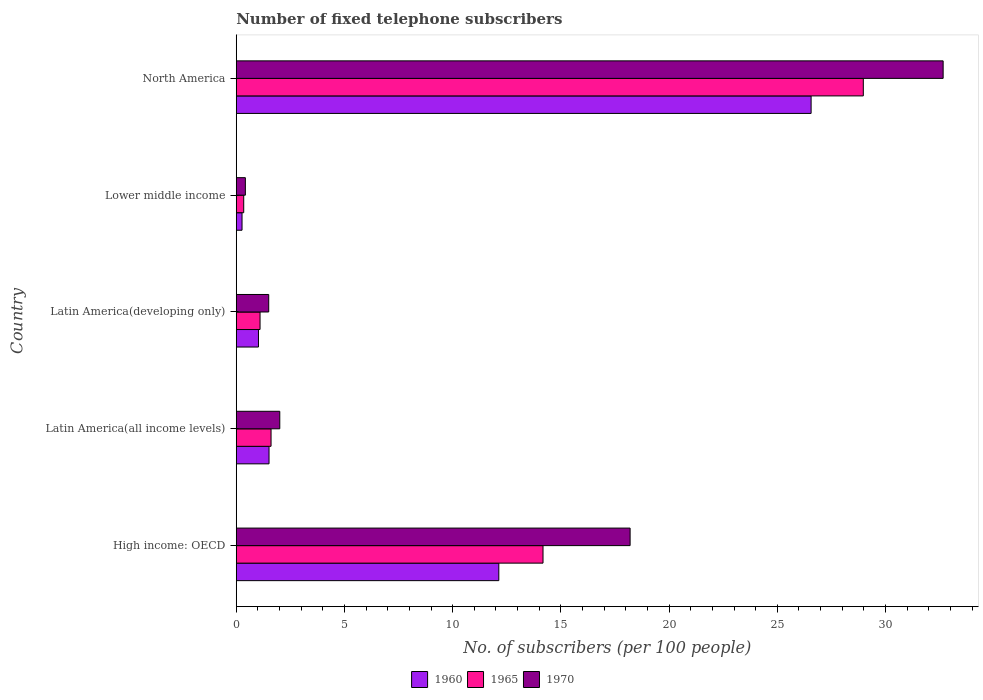How many different coloured bars are there?
Your response must be concise. 3. How many groups of bars are there?
Ensure brevity in your answer.  5. Are the number of bars on each tick of the Y-axis equal?
Offer a terse response. Yes. How many bars are there on the 3rd tick from the top?
Offer a terse response. 3. How many bars are there on the 4th tick from the bottom?
Give a very brief answer. 3. What is the label of the 2nd group of bars from the top?
Offer a terse response. Lower middle income. What is the number of fixed telephone subscribers in 1965 in North America?
Offer a very short reply. 28.97. Across all countries, what is the maximum number of fixed telephone subscribers in 1970?
Offer a terse response. 32.66. Across all countries, what is the minimum number of fixed telephone subscribers in 1965?
Keep it short and to the point. 0.34. In which country was the number of fixed telephone subscribers in 1970 minimum?
Your answer should be very brief. Lower middle income. What is the total number of fixed telephone subscribers in 1970 in the graph?
Make the answer very short. 54.79. What is the difference between the number of fixed telephone subscribers in 1970 in High income: OECD and that in Latin America(developing only)?
Give a very brief answer. 16.7. What is the difference between the number of fixed telephone subscribers in 1960 in North America and the number of fixed telephone subscribers in 1965 in Latin America(all income levels)?
Your response must be concise. 24.95. What is the average number of fixed telephone subscribers in 1960 per country?
Provide a succinct answer. 8.3. What is the difference between the number of fixed telephone subscribers in 1965 and number of fixed telephone subscribers in 1970 in High income: OECD?
Offer a terse response. -4.02. What is the ratio of the number of fixed telephone subscribers in 1970 in High income: OECD to that in North America?
Give a very brief answer. 0.56. What is the difference between the highest and the second highest number of fixed telephone subscribers in 1960?
Make the answer very short. 14.43. What is the difference between the highest and the lowest number of fixed telephone subscribers in 1970?
Give a very brief answer. 32.24. Is the sum of the number of fixed telephone subscribers in 1970 in High income: OECD and Latin America(all income levels) greater than the maximum number of fixed telephone subscribers in 1965 across all countries?
Offer a very short reply. No. What does the 2nd bar from the top in Lower middle income represents?
Your answer should be very brief. 1965. What does the 1st bar from the bottom in North America represents?
Your answer should be very brief. 1960. How many bars are there?
Your response must be concise. 15. Are all the bars in the graph horizontal?
Ensure brevity in your answer.  Yes. How many countries are there in the graph?
Your response must be concise. 5. Does the graph contain any zero values?
Provide a short and direct response. No. Does the graph contain grids?
Your response must be concise. No. Where does the legend appear in the graph?
Provide a succinct answer. Bottom center. How many legend labels are there?
Your answer should be very brief. 3. How are the legend labels stacked?
Offer a terse response. Horizontal. What is the title of the graph?
Provide a succinct answer. Number of fixed telephone subscribers. Does "2011" appear as one of the legend labels in the graph?
Provide a succinct answer. No. What is the label or title of the X-axis?
Your answer should be compact. No. of subscribers (per 100 people). What is the label or title of the Y-axis?
Make the answer very short. Country. What is the No. of subscribers (per 100 people) in 1960 in High income: OECD?
Give a very brief answer. 12.13. What is the No. of subscribers (per 100 people) in 1965 in High income: OECD?
Your answer should be very brief. 14.17. What is the No. of subscribers (per 100 people) in 1970 in High income: OECD?
Make the answer very short. 18.2. What is the No. of subscribers (per 100 people) of 1960 in Latin America(all income levels)?
Your answer should be very brief. 1.51. What is the No. of subscribers (per 100 people) in 1965 in Latin America(all income levels)?
Provide a succinct answer. 1.61. What is the No. of subscribers (per 100 people) in 1970 in Latin America(all income levels)?
Ensure brevity in your answer.  2.01. What is the No. of subscribers (per 100 people) in 1960 in Latin America(developing only)?
Make the answer very short. 1.03. What is the No. of subscribers (per 100 people) of 1965 in Latin America(developing only)?
Ensure brevity in your answer.  1.1. What is the No. of subscribers (per 100 people) in 1970 in Latin America(developing only)?
Provide a succinct answer. 1.5. What is the No. of subscribers (per 100 people) of 1960 in Lower middle income?
Your response must be concise. 0.27. What is the No. of subscribers (per 100 people) of 1965 in Lower middle income?
Your response must be concise. 0.34. What is the No. of subscribers (per 100 people) in 1970 in Lower middle income?
Offer a very short reply. 0.42. What is the No. of subscribers (per 100 people) in 1960 in North America?
Your response must be concise. 26.56. What is the No. of subscribers (per 100 people) in 1965 in North America?
Your answer should be compact. 28.97. What is the No. of subscribers (per 100 people) in 1970 in North America?
Your answer should be very brief. 32.66. Across all countries, what is the maximum No. of subscribers (per 100 people) in 1960?
Ensure brevity in your answer.  26.56. Across all countries, what is the maximum No. of subscribers (per 100 people) in 1965?
Your response must be concise. 28.97. Across all countries, what is the maximum No. of subscribers (per 100 people) of 1970?
Your answer should be very brief. 32.66. Across all countries, what is the minimum No. of subscribers (per 100 people) of 1960?
Your response must be concise. 0.27. Across all countries, what is the minimum No. of subscribers (per 100 people) of 1965?
Your response must be concise. 0.34. Across all countries, what is the minimum No. of subscribers (per 100 people) of 1970?
Keep it short and to the point. 0.42. What is the total No. of subscribers (per 100 people) of 1960 in the graph?
Ensure brevity in your answer.  41.5. What is the total No. of subscribers (per 100 people) of 1965 in the graph?
Ensure brevity in your answer.  46.2. What is the total No. of subscribers (per 100 people) in 1970 in the graph?
Offer a very short reply. 54.79. What is the difference between the No. of subscribers (per 100 people) of 1960 in High income: OECD and that in Latin America(all income levels)?
Offer a very short reply. 10.62. What is the difference between the No. of subscribers (per 100 people) in 1965 in High income: OECD and that in Latin America(all income levels)?
Your response must be concise. 12.57. What is the difference between the No. of subscribers (per 100 people) in 1970 in High income: OECD and that in Latin America(all income levels)?
Offer a very short reply. 16.19. What is the difference between the No. of subscribers (per 100 people) in 1960 in High income: OECD and that in Latin America(developing only)?
Your answer should be compact. 11.1. What is the difference between the No. of subscribers (per 100 people) in 1965 in High income: OECD and that in Latin America(developing only)?
Your response must be concise. 13.07. What is the difference between the No. of subscribers (per 100 people) in 1970 in High income: OECD and that in Latin America(developing only)?
Keep it short and to the point. 16.7. What is the difference between the No. of subscribers (per 100 people) in 1960 in High income: OECD and that in Lower middle income?
Offer a terse response. 11.86. What is the difference between the No. of subscribers (per 100 people) in 1965 in High income: OECD and that in Lower middle income?
Your response must be concise. 13.83. What is the difference between the No. of subscribers (per 100 people) in 1970 in High income: OECD and that in Lower middle income?
Provide a succinct answer. 17.78. What is the difference between the No. of subscribers (per 100 people) in 1960 in High income: OECD and that in North America?
Keep it short and to the point. -14.43. What is the difference between the No. of subscribers (per 100 people) of 1965 in High income: OECD and that in North America?
Give a very brief answer. -14.8. What is the difference between the No. of subscribers (per 100 people) in 1970 in High income: OECD and that in North America?
Offer a very short reply. -14.46. What is the difference between the No. of subscribers (per 100 people) of 1960 in Latin America(all income levels) and that in Latin America(developing only)?
Provide a succinct answer. 0.49. What is the difference between the No. of subscribers (per 100 people) of 1965 in Latin America(all income levels) and that in Latin America(developing only)?
Your response must be concise. 0.51. What is the difference between the No. of subscribers (per 100 people) in 1970 in Latin America(all income levels) and that in Latin America(developing only)?
Make the answer very short. 0.51. What is the difference between the No. of subscribers (per 100 people) of 1960 in Latin America(all income levels) and that in Lower middle income?
Offer a very short reply. 1.25. What is the difference between the No. of subscribers (per 100 people) in 1965 in Latin America(all income levels) and that in Lower middle income?
Your answer should be compact. 1.26. What is the difference between the No. of subscribers (per 100 people) of 1970 in Latin America(all income levels) and that in Lower middle income?
Offer a terse response. 1.59. What is the difference between the No. of subscribers (per 100 people) in 1960 in Latin America(all income levels) and that in North America?
Your answer should be very brief. -25.05. What is the difference between the No. of subscribers (per 100 people) of 1965 in Latin America(all income levels) and that in North America?
Make the answer very short. -27.36. What is the difference between the No. of subscribers (per 100 people) of 1970 in Latin America(all income levels) and that in North America?
Your response must be concise. -30.65. What is the difference between the No. of subscribers (per 100 people) in 1960 in Latin America(developing only) and that in Lower middle income?
Your answer should be very brief. 0.76. What is the difference between the No. of subscribers (per 100 people) in 1965 in Latin America(developing only) and that in Lower middle income?
Offer a very short reply. 0.75. What is the difference between the No. of subscribers (per 100 people) of 1970 in Latin America(developing only) and that in Lower middle income?
Provide a short and direct response. 1.08. What is the difference between the No. of subscribers (per 100 people) of 1960 in Latin America(developing only) and that in North America?
Provide a succinct answer. -25.53. What is the difference between the No. of subscribers (per 100 people) of 1965 in Latin America(developing only) and that in North America?
Offer a terse response. -27.87. What is the difference between the No. of subscribers (per 100 people) in 1970 in Latin America(developing only) and that in North America?
Provide a succinct answer. -31.16. What is the difference between the No. of subscribers (per 100 people) in 1960 in Lower middle income and that in North America?
Make the answer very short. -26.29. What is the difference between the No. of subscribers (per 100 people) of 1965 in Lower middle income and that in North America?
Offer a terse response. -28.63. What is the difference between the No. of subscribers (per 100 people) of 1970 in Lower middle income and that in North America?
Provide a succinct answer. -32.24. What is the difference between the No. of subscribers (per 100 people) of 1960 in High income: OECD and the No. of subscribers (per 100 people) of 1965 in Latin America(all income levels)?
Provide a succinct answer. 10.52. What is the difference between the No. of subscribers (per 100 people) in 1960 in High income: OECD and the No. of subscribers (per 100 people) in 1970 in Latin America(all income levels)?
Provide a succinct answer. 10.12. What is the difference between the No. of subscribers (per 100 people) in 1965 in High income: OECD and the No. of subscribers (per 100 people) in 1970 in Latin America(all income levels)?
Your response must be concise. 12.16. What is the difference between the No. of subscribers (per 100 people) in 1960 in High income: OECD and the No. of subscribers (per 100 people) in 1965 in Latin America(developing only)?
Give a very brief answer. 11.03. What is the difference between the No. of subscribers (per 100 people) in 1960 in High income: OECD and the No. of subscribers (per 100 people) in 1970 in Latin America(developing only)?
Your response must be concise. 10.63. What is the difference between the No. of subscribers (per 100 people) of 1965 in High income: OECD and the No. of subscribers (per 100 people) of 1970 in Latin America(developing only)?
Give a very brief answer. 12.67. What is the difference between the No. of subscribers (per 100 people) in 1960 in High income: OECD and the No. of subscribers (per 100 people) in 1965 in Lower middle income?
Your answer should be compact. 11.79. What is the difference between the No. of subscribers (per 100 people) in 1960 in High income: OECD and the No. of subscribers (per 100 people) in 1970 in Lower middle income?
Your response must be concise. 11.71. What is the difference between the No. of subscribers (per 100 people) of 1965 in High income: OECD and the No. of subscribers (per 100 people) of 1970 in Lower middle income?
Provide a succinct answer. 13.75. What is the difference between the No. of subscribers (per 100 people) in 1960 in High income: OECD and the No. of subscribers (per 100 people) in 1965 in North America?
Your response must be concise. -16.84. What is the difference between the No. of subscribers (per 100 people) of 1960 in High income: OECD and the No. of subscribers (per 100 people) of 1970 in North America?
Keep it short and to the point. -20.53. What is the difference between the No. of subscribers (per 100 people) of 1965 in High income: OECD and the No. of subscribers (per 100 people) of 1970 in North America?
Offer a terse response. -18.49. What is the difference between the No. of subscribers (per 100 people) in 1960 in Latin America(all income levels) and the No. of subscribers (per 100 people) in 1965 in Latin America(developing only)?
Provide a succinct answer. 0.41. What is the difference between the No. of subscribers (per 100 people) in 1960 in Latin America(all income levels) and the No. of subscribers (per 100 people) in 1970 in Latin America(developing only)?
Make the answer very short. 0.01. What is the difference between the No. of subscribers (per 100 people) of 1965 in Latin America(all income levels) and the No. of subscribers (per 100 people) of 1970 in Latin America(developing only)?
Your answer should be very brief. 0.11. What is the difference between the No. of subscribers (per 100 people) of 1960 in Latin America(all income levels) and the No. of subscribers (per 100 people) of 1965 in Lower middle income?
Provide a short and direct response. 1.17. What is the difference between the No. of subscribers (per 100 people) in 1960 in Latin America(all income levels) and the No. of subscribers (per 100 people) in 1970 in Lower middle income?
Offer a very short reply. 1.09. What is the difference between the No. of subscribers (per 100 people) in 1965 in Latin America(all income levels) and the No. of subscribers (per 100 people) in 1970 in Lower middle income?
Ensure brevity in your answer.  1.19. What is the difference between the No. of subscribers (per 100 people) in 1960 in Latin America(all income levels) and the No. of subscribers (per 100 people) in 1965 in North America?
Keep it short and to the point. -27.46. What is the difference between the No. of subscribers (per 100 people) in 1960 in Latin America(all income levels) and the No. of subscribers (per 100 people) in 1970 in North America?
Offer a very short reply. -31.15. What is the difference between the No. of subscribers (per 100 people) of 1965 in Latin America(all income levels) and the No. of subscribers (per 100 people) of 1970 in North America?
Give a very brief answer. -31.05. What is the difference between the No. of subscribers (per 100 people) of 1960 in Latin America(developing only) and the No. of subscribers (per 100 people) of 1965 in Lower middle income?
Keep it short and to the point. 0.68. What is the difference between the No. of subscribers (per 100 people) of 1960 in Latin America(developing only) and the No. of subscribers (per 100 people) of 1970 in Lower middle income?
Provide a succinct answer. 0.61. What is the difference between the No. of subscribers (per 100 people) of 1965 in Latin America(developing only) and the No. of subscribers (per 100 people) of 1970 in Lower middle income?
Provide a succinct answer. 0.68. What is the difference between the No. of subscribers (per 100 people) in 1960 in Latin America(developing only) and the No. of subscribers (per 100 people) in 1965 in North America?
Provide a succinct answer. -27.94. What is the difference between the No. of subscribers (per 100 people) in 1960 in Latin America(developing only) and the No. of subscribers (per 100 people) in 1970 in North America?
Provide a short and direct response. -31.63. What is the difference between the No. of subscribers (per 100 people) in 1965 in Latin America(developing only) and the No. of subscribers (per 100 people) in 1970 in North America?
Provide a short and direct response. -31.56. What is the difference between the No. of subscribers (per 100 people) of 1960 in Lower middle income and the No. of subscribers (per 100 people) of 1965 in North America?
Provide a succinct answer. -28.7. What is the difference between the No. of subscribers (per 100 people) in 1960 in Lower middle income and the No. of subscribers (per 100 people) in 1970 in North America?
Give a very brief answer. -32.39. What is the difference between the No. of subscribers (per 100 people) in 1965 in Lower middle income and the No. of subscribers (per 100 people) in 1970 in North America?
Offer a very short reply. -32.32. What is the average No. of subscribers (per 100 people) in 1960 per country?
Your answer should be very brief. 8.3. What is the average No. of subscribers (per 100 people) in 1965 per country?
Your answer should be very brief. 9.24. What is the average No. of subscribers (per 100 people) of 1970 per country?
Your answer should be very brief. 10.96. What is the difference between the No. of subscribers (per 100 people) in 1960 and No. of subscribers (per 100 people) in 1965 in High income: OECD?
Your response must be concise. -2.04. What is the difference between the No. of subscribers (per 100 people) in 1960 and No. of subscribers (per 100 people) in 1970 in High income: OECD?
Your response must be concise. -6.07. What is the difference between the No. of subscribers (per 100 people) in 1965 and No. of subscribers (per 100 people) in 1970 in High income: OECD?
Provide a succinct answer. -4.02. What is the difference between the No. of subscribers (per 100 people) of 1960 and No. of subscribers (per 100 people) of 1965 in Latin America(all income levels)?
Make the answer very short. -0.09. What is the difference between the No. of subscribers (per 100 people) of 1960 and No. of subscribers (per 100 people) of 1970 in Latin America(all income levels)?
Make the answer very short. -0.5. What is the difference between the No. of subscribers (per 100 people) of 1965 and No. of subscribers (per 100 people) of 1970 in Latin America(all income levels)?
Your answer should be compact. -0.4. What is the difference between the No. of subscribers (per 100 people) of 1960 and No. of subscribers (per 100 people) of 1965 in Latin America(developing only)?
Ensure brevity in your answer.  -0.07. What is the difference between the No. of subscribers (per 100 people) in 1960 and No. of subscribers (per 100 people) in 1970 in Latin America(developing only)?
Provide a short and direct response. -0.47. What is the difference between the No. of subscribers (per 100 people) in 1965 and No. of subscribers (per 100 people) in 1970 in Latin America(developing only)?
Ensure brevity in your answer.  -0.4. What is the difference between the No. of subscribers (per 100 people) of 1960 and No. of subscribers (per 100 people) of 1965 in Lower middle income?
Your answer should be very brief. -0.08. What is the difference between the No. of subscribers (per 100 people) of 1960 and No. of subscribers (per 100 people) of 1970 in Lower middle income?
Provide a short and direct response. -0.15. What is the difference between the No. of subscribers (per 100 people) in 1965 and No. of subscribers (per 100 people) in 1970 in Lower middle income?
Your response must be concise. -0.08. What is the difference between the No. of subscribers (per 100 people) in 1960 and No. of subscribers (per 100 people) in 1965 in North America?
Your answer should be compact. -2.41. What is the difference between the No. of subscribers (per 100 people) of 1960 and No. of subscribers (per 100 people) of 1970 in North America?
Your response must be concise. -6.1. What is the difference between the No. of subscribers (per 100 people) of 1965 and No. of subscribers (per 100 people) of 1970 in North America?
Provide a succinct answer. -3.69. What is the ratio of the No. of subscribers (per 100 people) of 1960 in High income: OECD to that in Latin America(all income levels)?
Offer a terse response. 8.01. What is the ratio of the No. of subscribers (per 100 people) of 1965 in High income: OECD to that in Latin America(all income levels)?
Provide a short and direct response. 8.82. What is the ratio of the No. of subscribers (per 100 people) of 1970 in High income: OECD to that in Latin America(all income levels)?
Ensure brevity in your answer.  9.05. What is the ratio of the No. of subscribers (per 100 people) in 1960 in High income: OECD to that in Latin America(developing only)?
Offer a terse response. 11.82. What is the ratio of the No. of subscribers (per 100 people) in 1965 in High income: OECD to that in Latin America(developing only)?
Offer a very short reply. 12.89. What is the ratio of the No. of subscribers (per 100 people) in 1970 in High income: OECD to that in Latin America(developing only)?
Make the answer very short. 12.13. What is the ratio of the No. of subscribers (per 100 people) in 1960 in High income: OECD to that in Lower middle income?
Make the answer very short. 45.4. What is the ratio of the No. of subscribers (per 100 people) in 1965 in High income: OECD to that in Lower middle income?
Keep it short and to the point. 41.13. What is the ratio of the No. of subscribers (per 100 people) in 1970 in High income: OECD to that in Lower middle income?
Your response must be concise. 43.24. What is the ratio of the No. of subscribers (per 100 people) of 1960 in High income: OECD to that in North America?
Keep it short and to the point. 0.46. What is the ratio of the No. of subscribers (per 100 people) in 1965 in High income: OECD to that in North America?
Give a very brief answer. 0.49. What is the ratio of the No. of subscribers (per 100 people) of 1970 in High income: OECD to that in North America?
Offer a very short reply. 0.56. What is the ratio of the No. of subscribers (per 100 people) of 1960 in Latin America(all income levels) to that in Latin America(developing only)?
Offer a very short reply. 1.47. What is the ratio of the No. of subscribers (per 100 people) of 1965 in Latin America(all income levels) to that in Latin America(developing only)?
Provide a short and direct response. 1.46. What is the ratio of the No. of subscribers (per 100 people) of 1970 in Latin America(all income levels) to that in Latin America(developing only)?
Provide a short and direct response. 1.34. What is the ratio of the No. of subscribers (per 100 people) of 1960 in Latin America(all income levels) to that in Lower middle income?
Your answer should be very brief. 5.67. What is the ratio of the No. of subscribers (per 100 people) of 1965 in Latin America(all income levels) to that in Lower middle income?
Provide a short and direct response. 4.66. What is the ratio of the No. of subscribers (per 100 people) of 1970 in Latin America(all income levels) to that in Lower middle income?
Your response must be concise. 4.78. What is the ratio of the No. of subscribers (per 100 people) in 1960 in Latin America(all income levels) to that in North America?
Provide a short and direct response. 0.06. What is the ratio of the No. of subscribers (per 100 people) of 1965 in Latin America(all income levels) to that in North America?
Your answer should be compact. 0.06. What is the ratio of the No. of subscribers (per 100 people) of 1970 in Latin America(all income levels) to that in North America?
Ensure brevity in your answer.  0.06. What is the ratio of the No. of subscribers (per 100 people) in 1960 in Latin America(developing only) to that in Lower middle income?
Your response must be concise. 3.84. What is the ratio of the No. of subscribers (per 100 people) of 1965 in Latin America(developing only) to that in Lower middle income?
Your answer should be very brief. 3.19. What is the ratio of the No. of subscribers (per 100 people) of 1970 in Latin America(developing only) to that in Lower middle income?
Make the answer very short. 3.56. What is the ratio of the No. of subscribers (per 100 people) in 1960 in Latin America(developing only) to that in North America?
Your answer should be very brief. 0.04. What is the ratio of the No. of subscribers (per 100 people) in 1965 in Latin America(developing only) to that in North America?
Provide a succinct answer. 0.04. What is the ratio of the No. of subscribers (per 100 people) of 1970 in Latin America(developing only) to that in North America?
Offer a terse response. 0.05. What is the ratio of the No. of subscribers (per 100 people) in 1960 in Lower middle income to that in North America?
Provide a succinct answer. 0.01. What is the ratio of the No. of subscribers (per 100 people) of 1965 in Lower middle income to that in North America?
Provide a succinct answer. 0.01. What is the ratio of the No. of subscribers (per 100 people) in 1970 in Lower middle income to that in North America?
Your answer should be very brief. 0.01. What is the difference between the highest and the second highest No. of subscribers (per 100 people) in 1960?
Keep it short and to the point. 14.43. What is the difference between the highest and the second highest No. of subscribers (per 100 people) in 1965?
Provide a succinct answer. 14.8. What is the difference between the highest and the second highest No. of subscribers (per 100 people) of 1970?
Provide a succinct answer. 14.46. What is the difference between the highest and the lowest No. of subscribers (per 100 people) in 1960?
Give a very brief answer. 26.29. What is the difference between the highest and the lowest No. of subscribers (per 100 people) in 1965?
Your answer should be very brief. 28.63. What is the difference between the highest and the lowest No. of subscribers (per 100 people) in 1970?
Give a very brief answer. 32.24. 